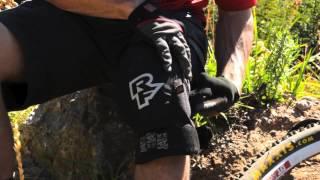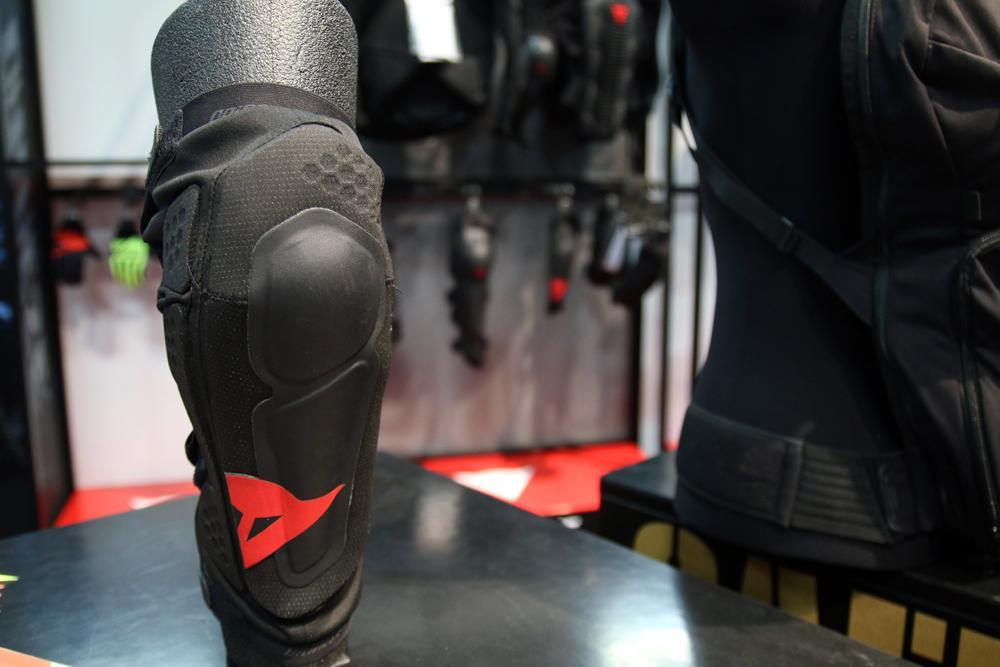The first image is the image on the left, the second image is the image on the right. Assess this claim about the two images: "Two legs in one image wear knee pads with a perforated front, and the other image shows a pad that is not on a person's knee.". Correct or not? Answer yes or no. No. The first image is the image on the left, the second image is the image on the right. Examine the images to the left and right. Is the description "There is an elbow pad." accurate? Answer yes or no. Yes. 